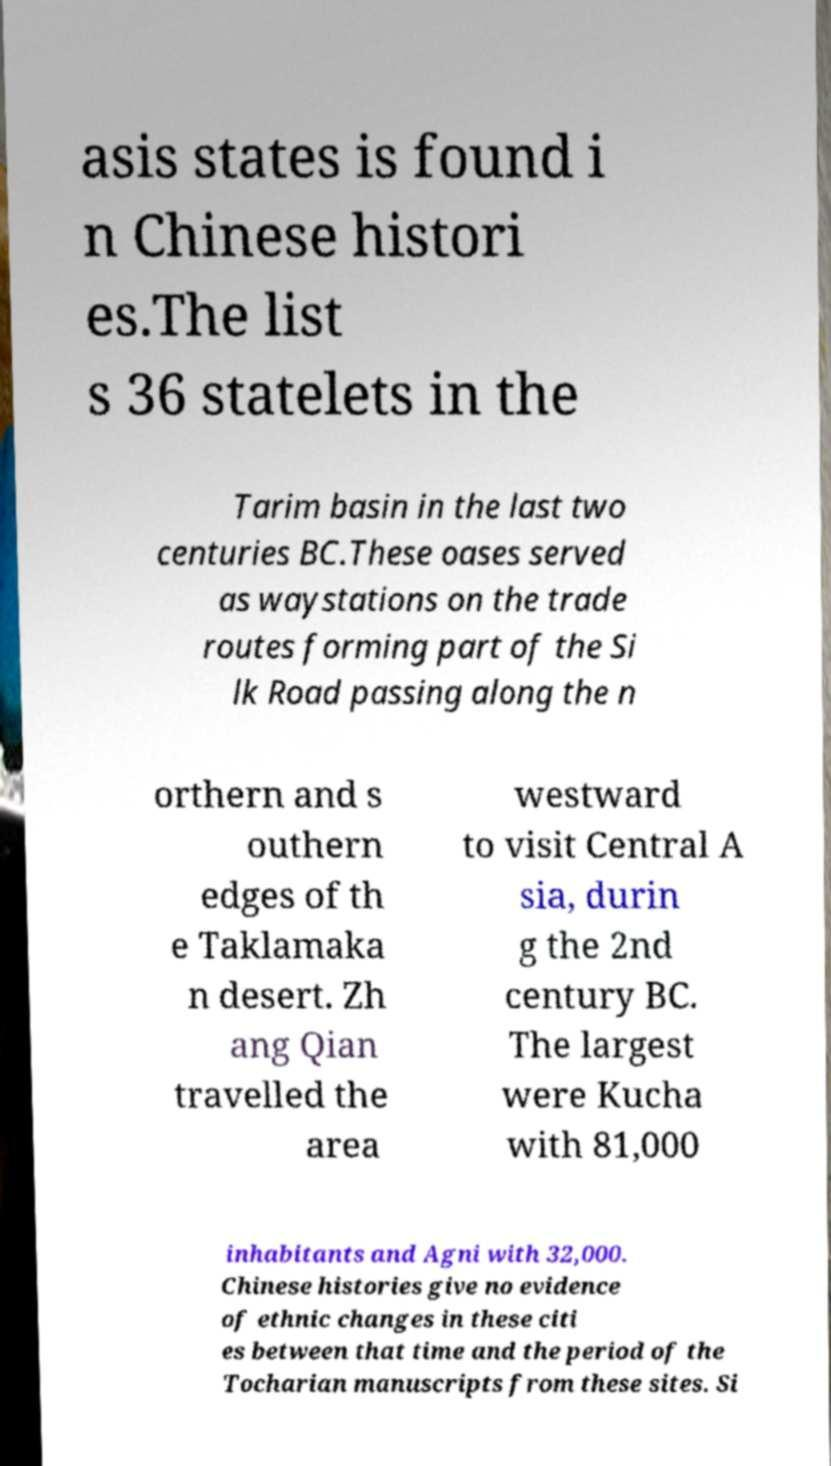For documentation purposes, I need the text within this image transcribed. Could you provide that? asis states is found i n Chinese histori es.The list s 36 statelets in the Tarim basin in the last two centuries BC.These oases served as waystations on the trade routes forming part of the Si lk Road passing along the n orthern and s outhern edges of th e Taklamaka n desert. Zh ang Qian travelled the area westward to visit Central A sia, durin g the 2nd century BC. The largest were Kucha with 81,000 inhabitants and Agni with 32,000. Chinese histories give no evidence of ethnic changes in these citi es between that time and the period of the Tocharian manuscripts from these sites. Si 